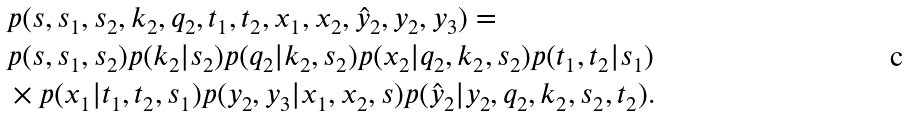Convert formula to latex. <formula><loc_0><loc_0><loc_500><loc_500>& \, p ( s , s _ { 1 } , s _ { 2 } , k _ { 2 } , q _ { 2 } , t _ { 1 } , t _ { 2 } , x _ { 1 } , x _ { 2 } , \hat { y } _ { 2 } , y _ { 2 } , y _ { 3 } ) = \\ & \, p ( s , s _ { 1 } , s _ { 2 } ) p ( k _ { 2 } | s _ { 2 } ) p ( q _ { 2 } | k _ { 2 } , s _ { 2 } ) p ( x _ { 2 } | q _ { 2 } , k _ { 2 } , s _ { 2 } ) p ( t _ { 1 } , t _ { 2 } | s _ { 1 } ) \\ & \, \times p ( x _ { 1 } | t _ { 1 } , t _ { 2 } , s _ { 1 } ) p ( y _ { 2 } , y _ { 3 } | x _ { 1 } , x _ { 2 } , s ) p ( \hat { y } _ { 2 } | y _ { 2 } , q _ { 2 } , k _ { 2 } , s _ { 2 } , t _ { 2 } ) .</formula> 